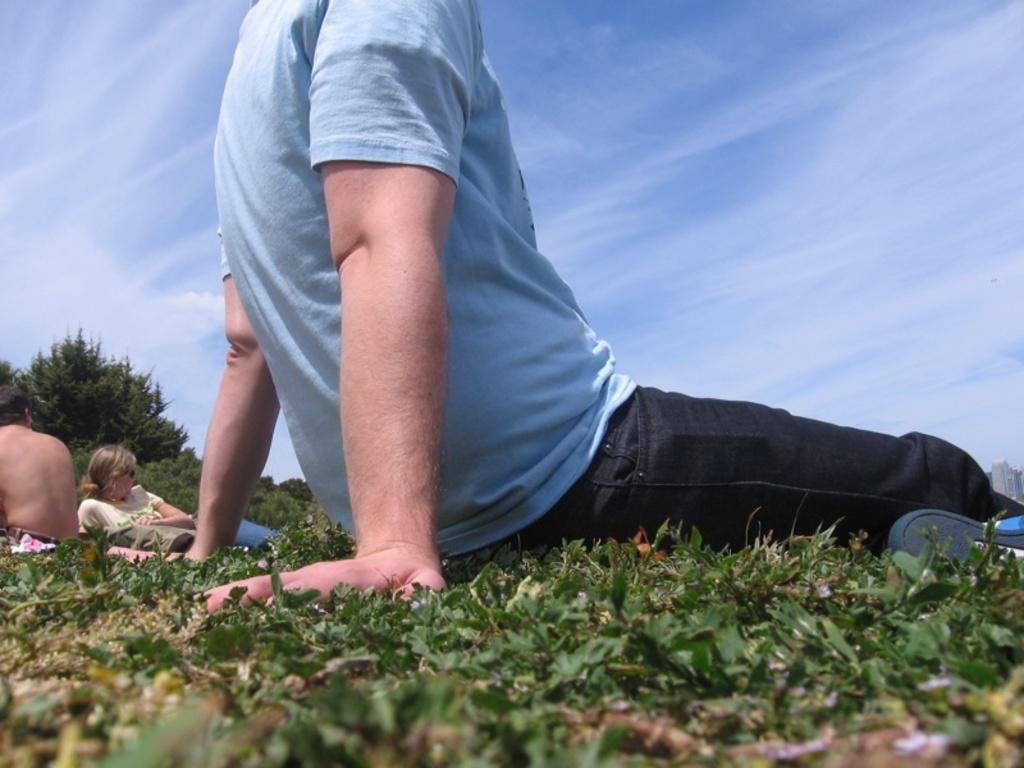Could you give a brief overview of what you see in this image? There is a person in gray color t-shirt, sitting and placing two hands on the grass on the ground. In the background, there are persons sitting on the grass on the ground, there are trees and there are clouds in the blue sky. 